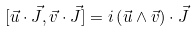<formula> <loc_0><loc_0><loc_500><loc_500>[ \vec { u } \cdot \vec { J } , \vec { v } \cdot \vec { J } ] = i \left ( \vec { u } \wedge \vec { v } \right ) \cdot \vec { J }</formula> 